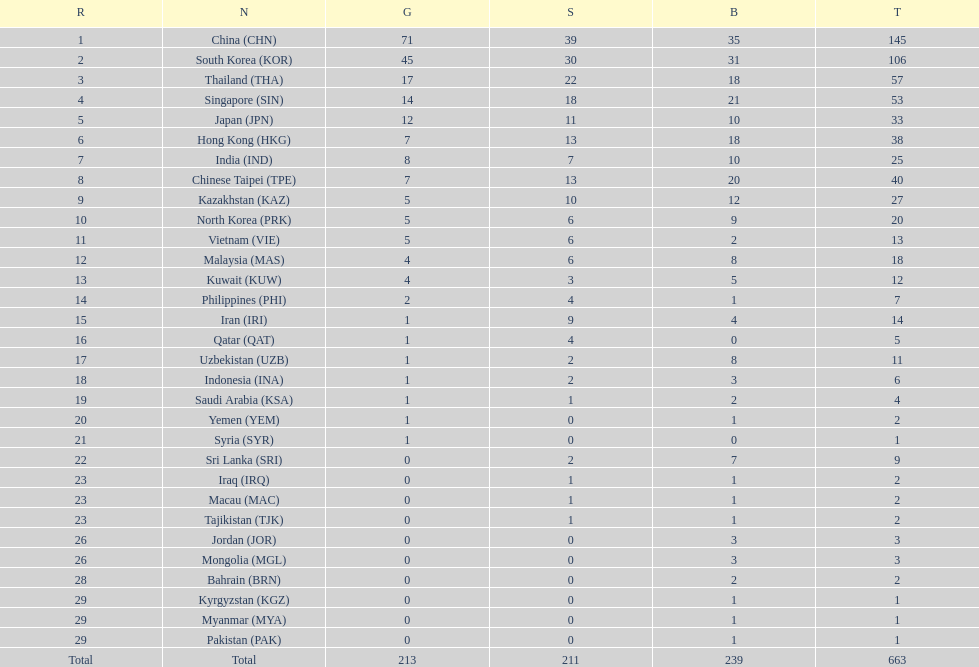How many more gold medals must qatar win before they can earn 12 gold medals? 11. 